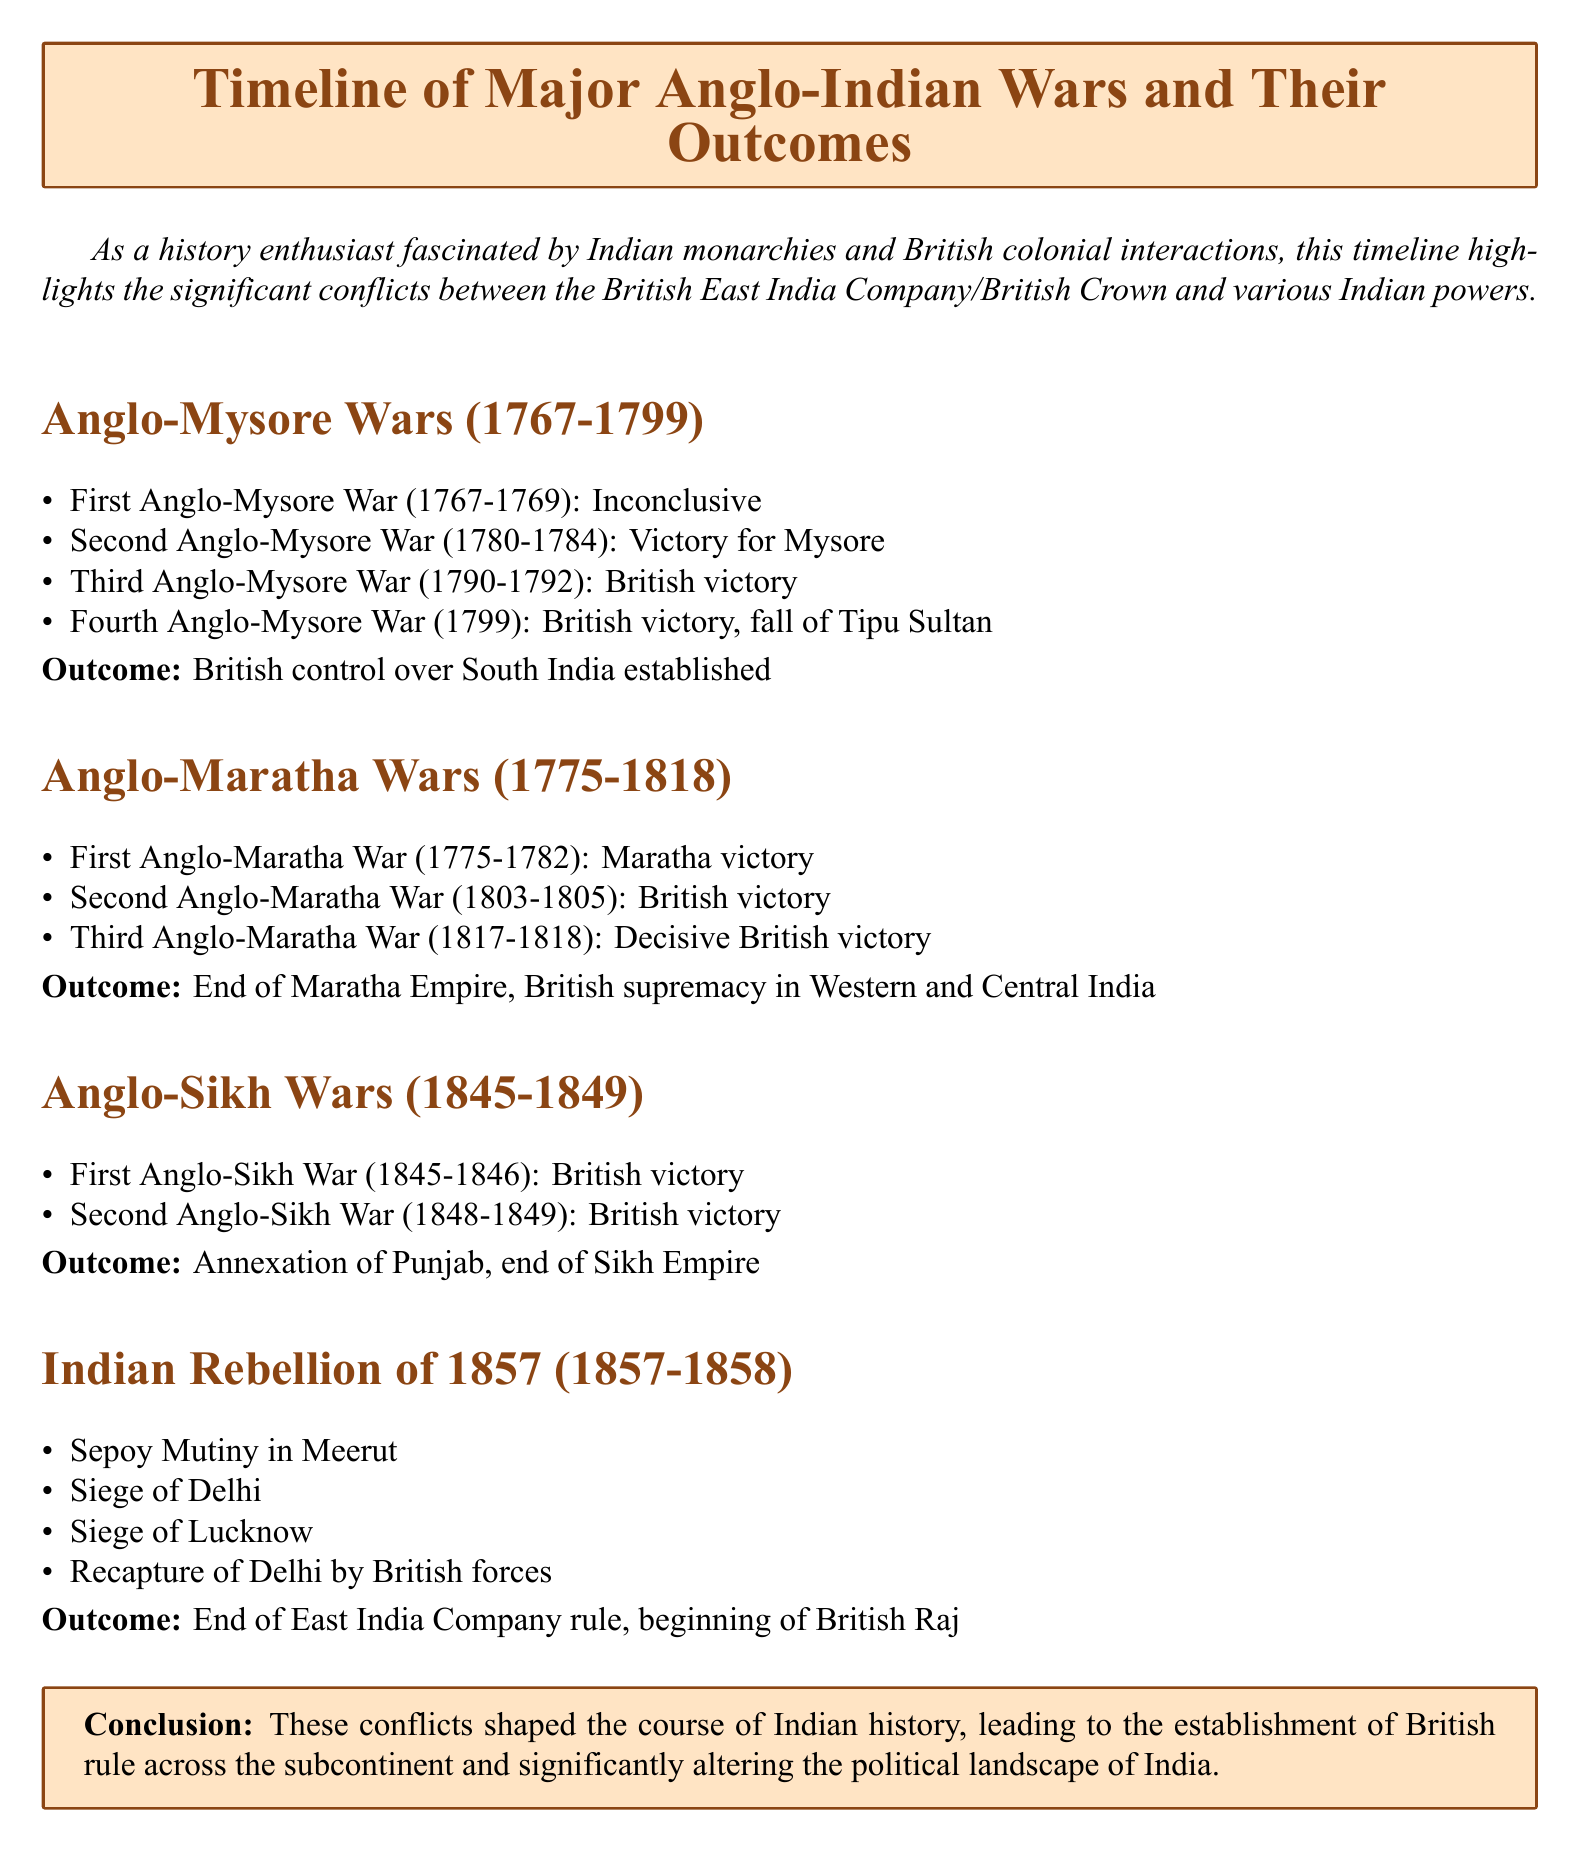What were the Anglo-Mysore Wars? The Anglo-Mysore Wars were a series of conflicts between the British and the Kingdom of Mysore from 1767 to 1799.
Answer: Anglo-Mysore Wars What was the outcome of the Third Anglo-Mysore War? The outcome of the Third Anglo-Mysore War was a British victory.
Answer: British victory How many Anglo-Maratha Wars took place? The document lists three major conflicts known as Anglo-Maratha Wars.
Answer: Three What major event concluded the Indian Rebellion of 1857? The major event that concluded the Indian Rebellion of 1857 was the recapture of Delhi by British forces.
Answer: Recapture of Delhi by British forces What was the period of the Anglo-Sikh Wars? The period of the Anglo-Sikh Wars was from 1845 to 1849.
Answer: 1845-1849 What significant change occurred after the Indian Rebellion of 1857? The significant change after the Indian Rebellion of 1857 was the beginning of the British Raj.
Answer: Beginning of British Raj Which war resulted in the annexation of Punjab? The Anglo-Sikh Wars resulted in the annexation of Punjab.
Answer: Anglo-Sikh Wars What was the outcome of the First Anglo-Maratha War? The outcome of the First Anglo-Maratha War was a Maratha victory.
Answer: Maratha victory What years did the Anglo-Maratha Wars span? The Anglo-Maratha Wars spanned from 1775 to 1818.
Answer: 1775-1818 